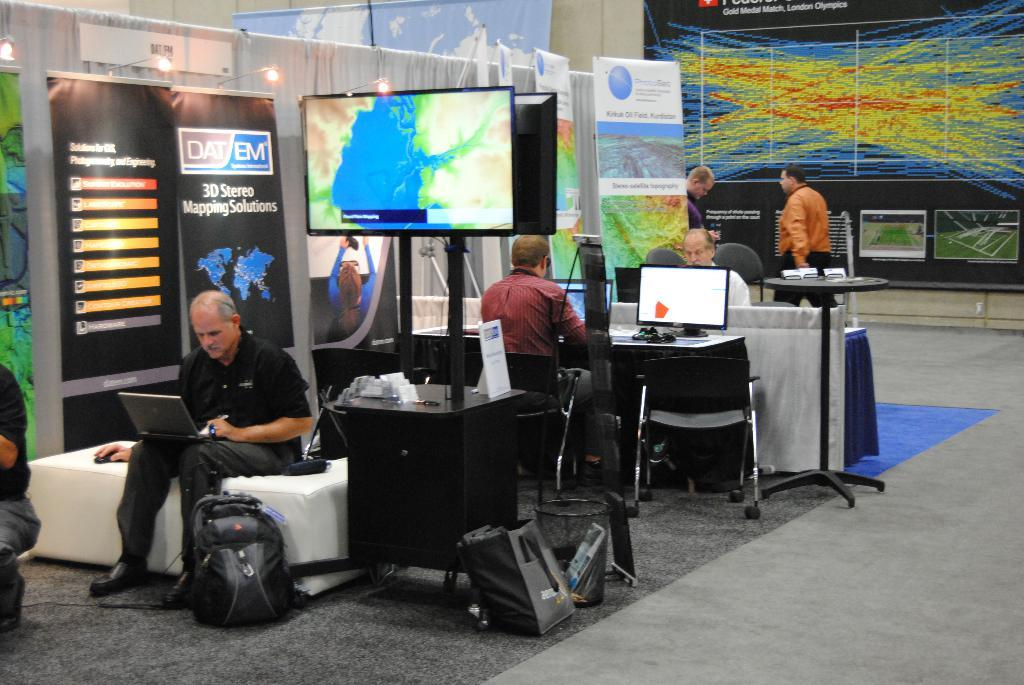What is located in the middle of the image? In the middle of the image, there is a table, a television, a man, a system, a chair, and a laptop. Can you describe the man in the middle of the image? The man in the middle of the image is sitting. What is on the right side of the image? On the right side of the image, there is a poster, a table, people, and a chair. What is the man on the left side of the image doing? The man on the left side of the image is not visible in the provided facts. How many chairs are present in the image? There are at least two chairs in the image, one in the middle and one on the right side. What type of pie is being served on the table in the image? There is no pie present in the image; the table contains a television, a system, and a laptop. How many grapes are visible on the man's mouth in the image? There is no man with grapes on his mouth in the image. 